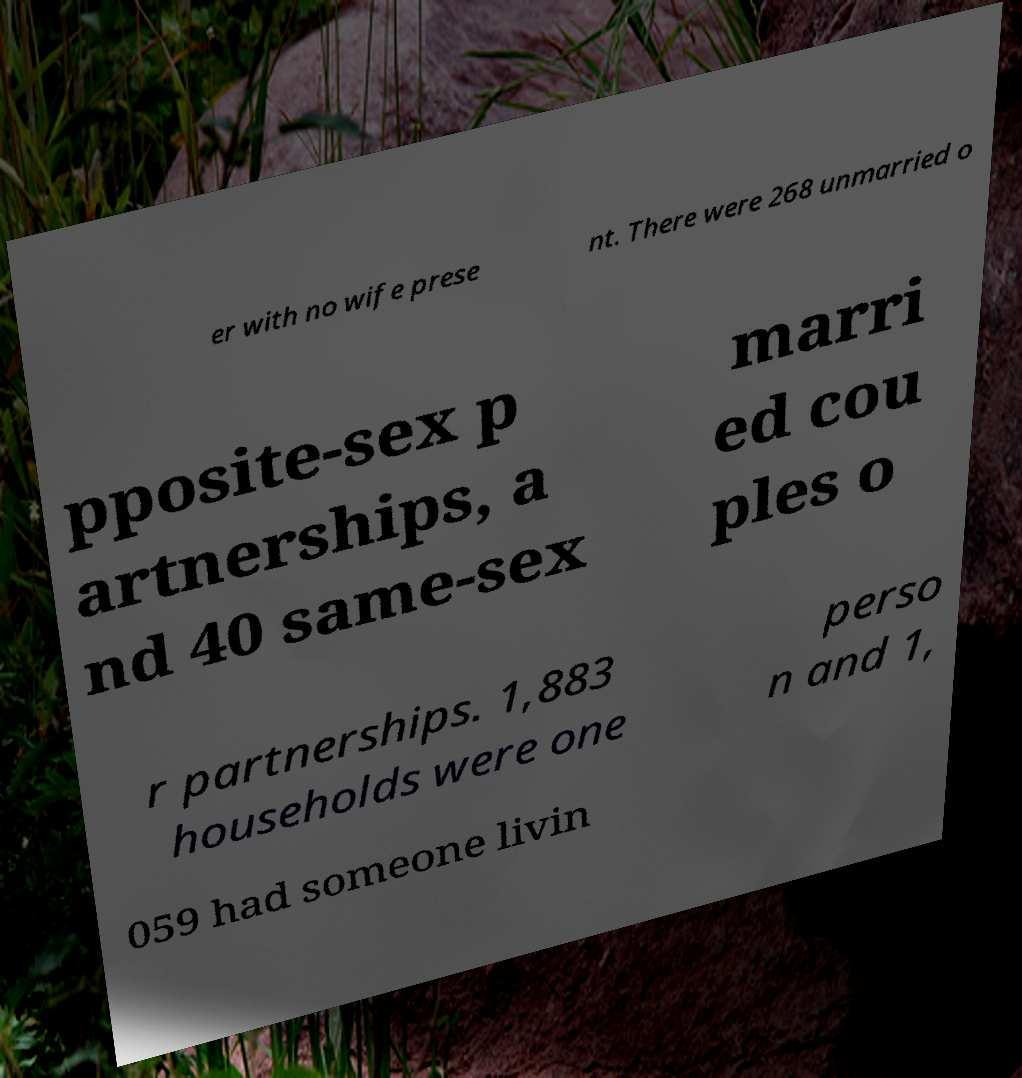Could you assist in decoding the text presented in this image and type it out clearly? er with no wife prese nt. There were 268 unmarried o pposite-sex p artnerships, a nd 40 same-sex marri ed cou ples o r partnerships. 1,883 households were one perso n and 1, 059 had someone livin 